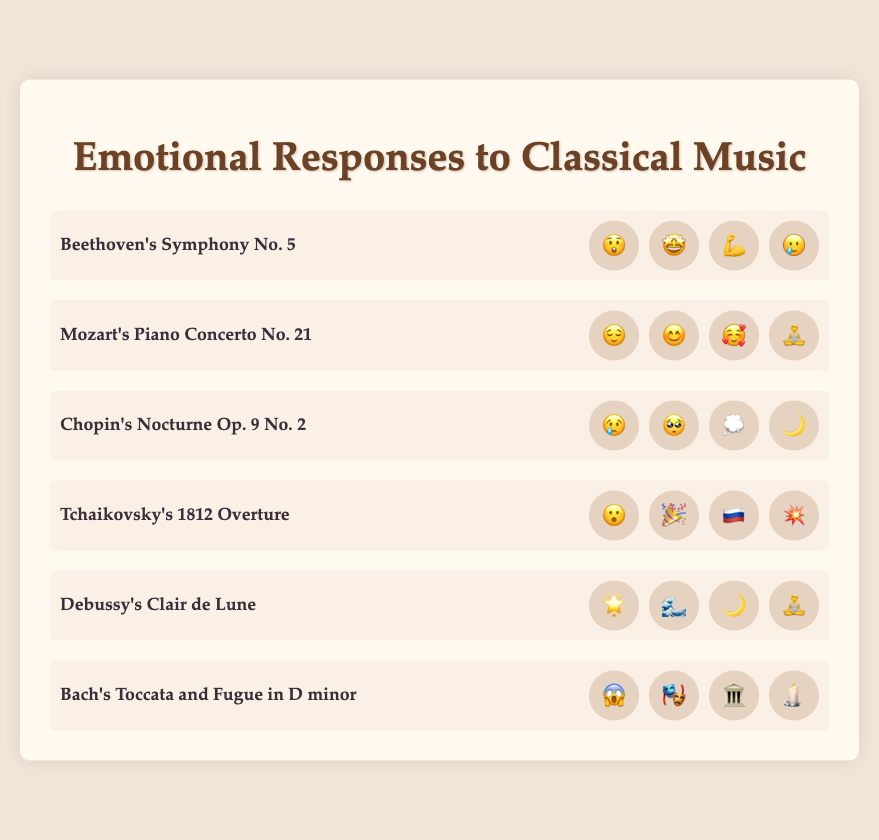Which piece has the emotion "🌙"? By looking at the emojis next to each piece, we can see that "🌙" appears next to Chopin's Nocturne Op. 9 No. 2 and Debussy's Clair de Lune.
Answer: Chopin's Nocturne Op. 9 No. 2, Debussy's Clair de Lune How many emotions are associated with Beethoven's Symphony No. 5? By inspecting the visual representation, we see that there are four emojis next to Beethoven's Symphony No. 5: 😲, 🤩, 💪, 🥲.
Answer: 4 Which piece is associated with "😌" and what are the other emotions associated with it? The piece associated with "😌" is Mozart's Piano Concerto No. 21. The other emotions associated with it are 😊, 🥰, and 🧘.
Answer: Mozart's Piano Concerto No. 21; 😊, 🥰, 🧘 Which piece is represented with the most surprising emotions (e.g., 😮, 😱)? Inspecting the pieces for surprise-related emojis, we find Tchaikovsky's 1812 Overture (😮) and Bach's Toccata and Fugue in D minor (😱) hold such emotions.
Answer: Tchaikovsky's 1812 Overture, Bach's Toccata and Fugue in D minor What is the common emotion between Debussy's Clair de Lune and Chopin's Nocturne Op. 9 No. 2? Looking at the emotions listed for both pieces, we see that "🌙" is a common emoji for both.
Answer: 🌙 List all emotions associated with emotions related to national pride and fireworks. Inspecting the visual information, we see that Tchaikovsky's 1812 Overture includes 🇷🇺 and 💥, which fit the criteria. The full list is 😮, 🎉, 🇷🇺, 💥.
Answer: 😮, 🎉, 🇷🇺, 💥 Which piece has the theme of reflection based on emojis, and what emojis represent this? By aligning thematic elements with the appropriate emojis, Chopin's Nocturne Op. 9 No. 2 fits the theme of reflection, represented by 😢, 🥺, 💭, 🌙.
Answer: Chopin's Nocturne Op. 9 No. 2; 😢, 🥺, 💭, 🌙 Compare the range of emotions for Tchaikovsky's 1812 Overture and Bach's Toccata and Fugue in D minor. Which has a wider range? Tchaikovsky's 1812 Overture has 😮, 🎉, 🇷🇺, 💥, and Bach's Toccata and Fugue in D minor has 😱, 🎭, 🏛️, 🕯️. Both sets have four unique emojis, indicating no difference in their emotional range.
Answer: Equal range of emotions Which piece uses emojis to express both calm and admiration, and what are these emojis? By examining each piece, Mozart's Piano Concerto No. 21 has emotions indicating calm (😌, 🧘) and admiration (😊, 🥰).
Answer: Mozart's Piano Concerto No. 21; 😌, 🧘, 😊, 🥰 